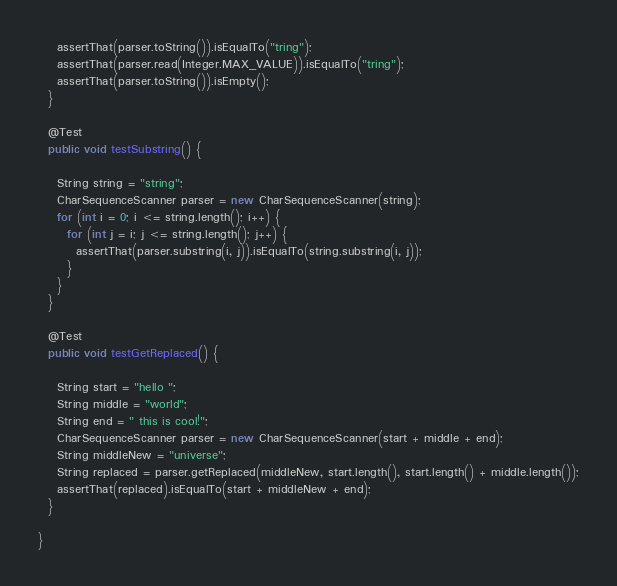<code> <loc_0><loc_0><loc_500><loc_500><_Java_>    assertThat(parser.toString()).isEqualTo("tring");
    assertThat(parser.read(Integer.MAX_VALUE)).isEqualTo("tring");
    assertThat(parser.toString()).isEmpty();
  }

  @Test
  public void testSubstring() {

    String string = "string";
    CharSequenceScanner parser = new CharSequenceScanner(string);
    for (int i = 0; i <= string.length(); i++) {
      for (int j = i; j <= string.length(); j++) {
        assertThat(parser.substring(i, j)).isEqualTo(string.substring(i, j));
      }
    }
  }

  @Test
  public void testGetReplaced() {

    String start = "hello ";
    String middle = "world";
    String end = " this is cool!";
    CharSequenceScanner parser = new CharSequenceScanner(start + middle + end);
    String middleNew = "universe";
    String replaced = parser.getReplaced(middleNew, start.length(), start.length() + middle.length());
    assertThat(replaced).isEqualTo(start + middleNew + end);
  }

}
</code> 